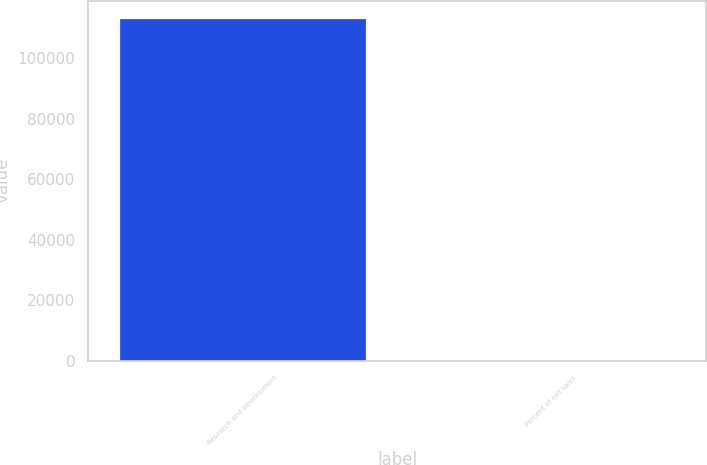<chart> <loc_0><loc_0><loc_500><loc_500><bar_chart><fcel>Research and development<fcel>Percent of net sales<nl><fcel>113314<fcel>6.4<nl></chart> 